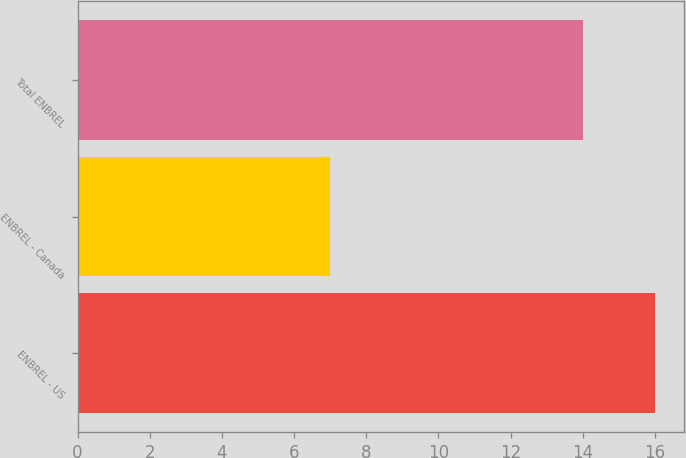Convert chart. <chart><loc_0><loc_0><loc_500><loc_500><bar_chart><fcel>ENBREL - US<fcel>ENBREL - Canada<fcel>Total ENBREL<nl><fcel>16<fcel>7<fcel>14<nl></chart> 